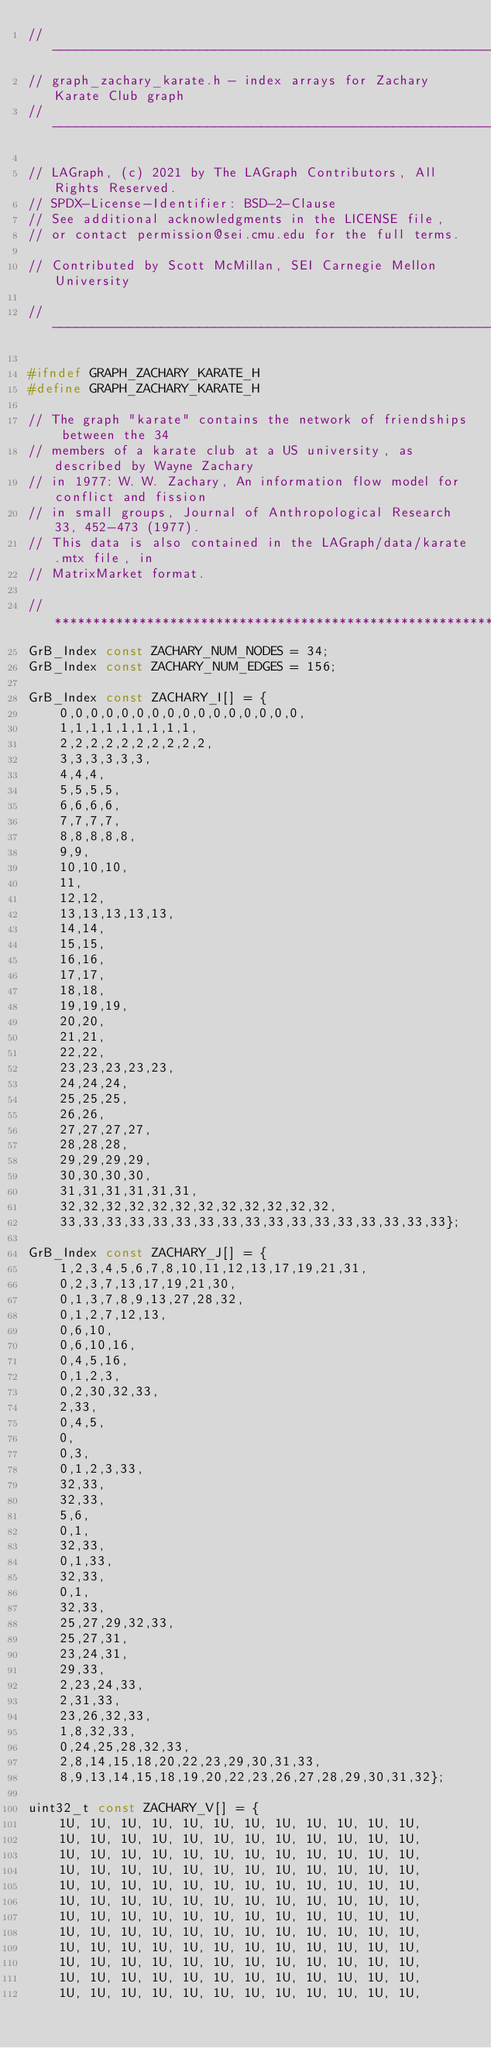Convert code to text. <code><loc_0><loc_0><loc_500><loc_500><_C_>//----------------------------------------------------------------------------
// graph_zachary_karate.h - index arrays for Zachary Karate Club graph
// ----------------------------------------------------------------------------

// LAGraph, (c) 2021 by The LAGraph Contributors, All Rights Reserved.
// SPDX-License-Identifier: BSD-2-Clause
// See additional acknowledgments in the LICENSE file,
// or contact permission@sei.cmu.edu for the full terms.

// Contributed by Scott McMillan, SEI Carnegie Mellon University

//-----------------------------------------------------------------------------

#ifndef GRAPH_ZACHARY_KARATE_H
#define GRAPH_ZACHARY_KARATE_H

// The graph "karate" contains the network of friendships between the 34
// members of a karate club at a US university, as described by Wayne Zachary
// in 1977: W. W. Zachary, An information flow model for conflict and fission
// in small groups, Journal of Anthropological Research 33, 452-473 (1977).
// This data is also contained in the LAGraph/data/karate.mtx file, in
// MatrixMarket format.

//****************************************************************************
GrB_Index const ZACHARY_NUM_NODES = 34;
GrB_Index const ZACHARY_NUM_EDGES = 156;

GrB_Index const ZACHARY_I[] = {
    0,0,0,0,0,0,0,0,0,0,0,0,0,0,0,0,
    1,1,1,1,1,1,1,1,1,
    2,2,2,2,2,2,2,2,2,2,
    3,3,3,3,3,3,
    4,4,4,
    5,5,5,5,
    6,6,6,6,
    7,7,7,7,
    8,8,8,8,8,
    9,9,
    10,10,10,
    11,
    12,12,
    13,13,13,13,13,
    14,14,
    15,15,
    16,16,
    17,17,
    18,18,
    19,19,19,
    20,20,
    21,21,
    22,22,
    23,23,23,23,23,
    24,24,24,
    25,25,25,
    26,26,
    27,27,27,27,
    28,28,28,
    29,29,29,29,
    30,30,30,30,
    31,31,31,31,31,31,
    32,32,32,32,32,32,32,32,32,32,32,32,
    33,33,33,33,33,33,33,33,33,33,33,33,33,33,33,33,33};

GrB_Index const ZACHARY_J[] = {
    1,2,3,4,5,6,7,8,10,11,12,13,17,19,21,31,
    0,2,3,7,13,17,19,21,30,
    0,1,3,7,8,9,13,27,28,32,
    0,1,2,7,12,13,
    0,6,10,
    0,6,10,16,
    0,4,5,16,
    0,1,2,3,
    0,2,30,32,33,
    2,33,
    0,4,5,
    0,
    0,3,
    0,1,2,3,33,
    32,33,
    32,33,
    5,6,
    0,1,
    32,33,
    0,1,33,
    32,33,
    0,1,
    32,33,
    25,27,29,32,33,
    25,27,31,
    23,24,31,
    29,33,
    2,23,24,33,
    2,31,33,
    23,26,32,33,
    1,8,32,33,
    0,24,25,28,32,33,
    2,8,14,15,18,20,22,23,29,30,31,33,
    8,9,13,14,15,18,19,20,22,23,26,27,28,29,30,31,32};

uint32_t const ZACHARY_V[] = {
    1U, 1U, 1U, 1U, 1U, 1U, 1U, 1U, 1U, 1U, 1U, 1U,
    1U, 1U, 1U, 1U, 1U, 1U, 1U, 1U, 1U, 1U, 1U, 1U,
    1U, 1U, 1U, 1U, 1U, 1U, 1U, 1U, 1U, 1U, 1U, 1U,
    1U, 1U, 1U, 1U, 1U, 1U, 1U, 1U, 1U, 1U, 1U, 1U,
    1U, 1U, 1U, 1U, 1U, 1U, 1U, 1U, 1U, 1U, 1U, 1U,
    1U, 1U, 1U, 1U, 1U, 1U, 1U, 1U, 1U, 1U, 1U, 1U,
    1U, 1U, 1U, 1U, 1U, 1U, 1U, 1U, 1U, 1U, 1U, 1U,
    1U, 1U, 1U, 1U, 1U, 1U, 1U, 1U, 1U, 1U, 1U, 1U,
    1U, 1U, 1U, 1U, 1U, 1U, 1U, 1U, 1U, 1U, 1U, 1U,
    1U, 1U, 1U, 1U, 1U, 1U, 1U, 1U, 1U, 1U, 1U, 1U,
    1U, 1U, 1U, 1U, 1U, 1U, 1U, 1U, 1U, 1U, 1U, 1U,
    1U, 1U, 1U, 1U, 1U, 1U, 1U, 1U, 1U, 1U, 1U, 1U,</code> 